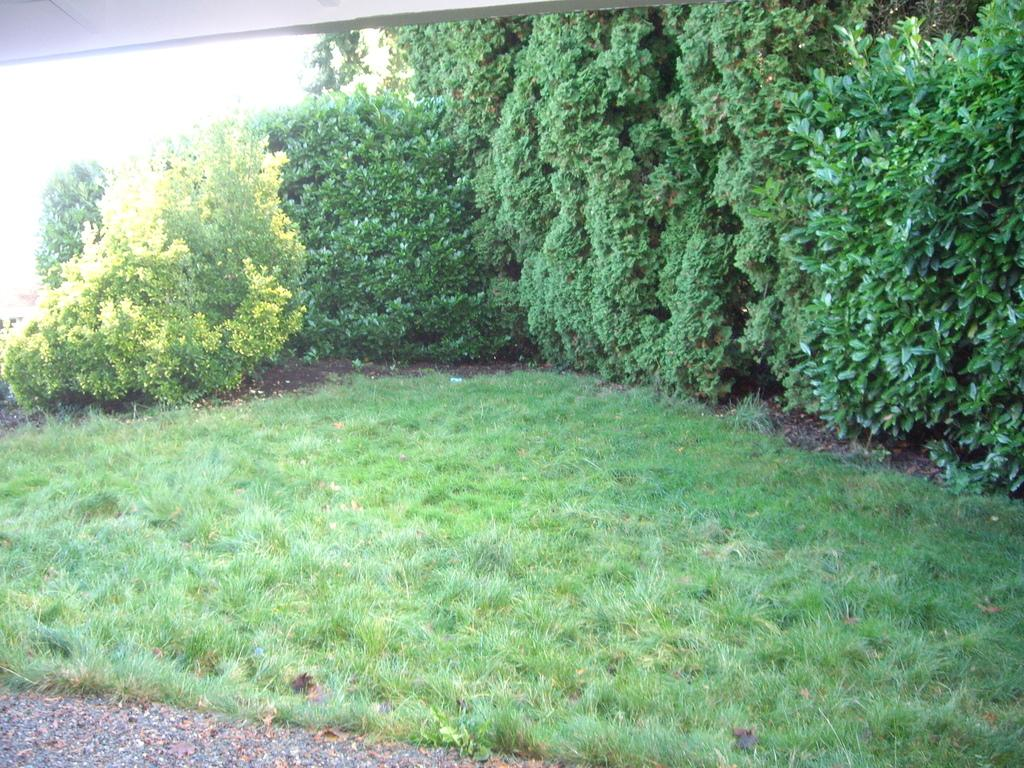What type of vegetation or plants can be seen in the image? There is greenery in the image, which suggests the presence of plants or vegetation. What type of muscle is being flexed by the person in the image? There is no person present in the image, and therefore no muscle flexing can be observed. 